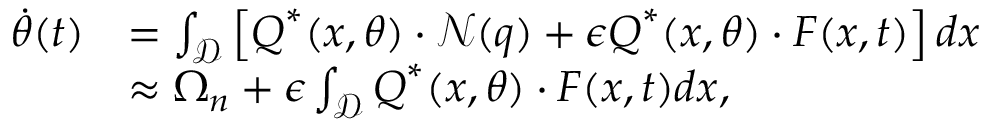<formula> <loc_0><loc_0><loc_500><loc_500>\begin{array} { r l } { \dot { \theta } ( t ) } & { = \int _ { \mathcal { D } } \left [ Q ^ { * } ( x , \theta ) \cdot \mathcal { N } ( q ) + \epsilon Q ^ { * } ( x , \theta ) \cdot F ( x , t ) \right ] d x } \\ & { \approx \Omega _ { n } + \epsilon \int _ { \mathcal { D } } Q ^ { * } ( x , \theta ) \cdot F ( x , t ) d x , } \end{array}</formula> 